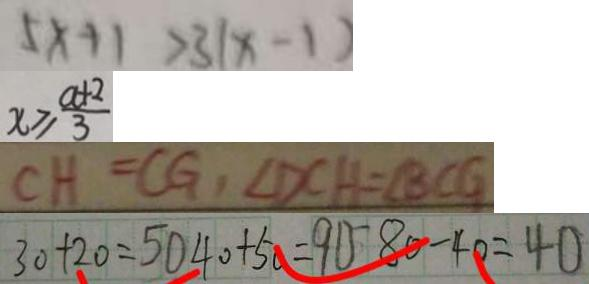<formula> <loc_0><loc_0><loc_500><loc_500>5 x + 1 > 3 ( x - 1 ) 
 x \geq \frac { a + 2 } { 3 } 
 C H = C G , \angle D C H = \angle B C G 
 3 0 + 2 0 = 5 0 4 0 + 5 0 = 9 0 8 0 - 4 0 = 4 0</formula> 